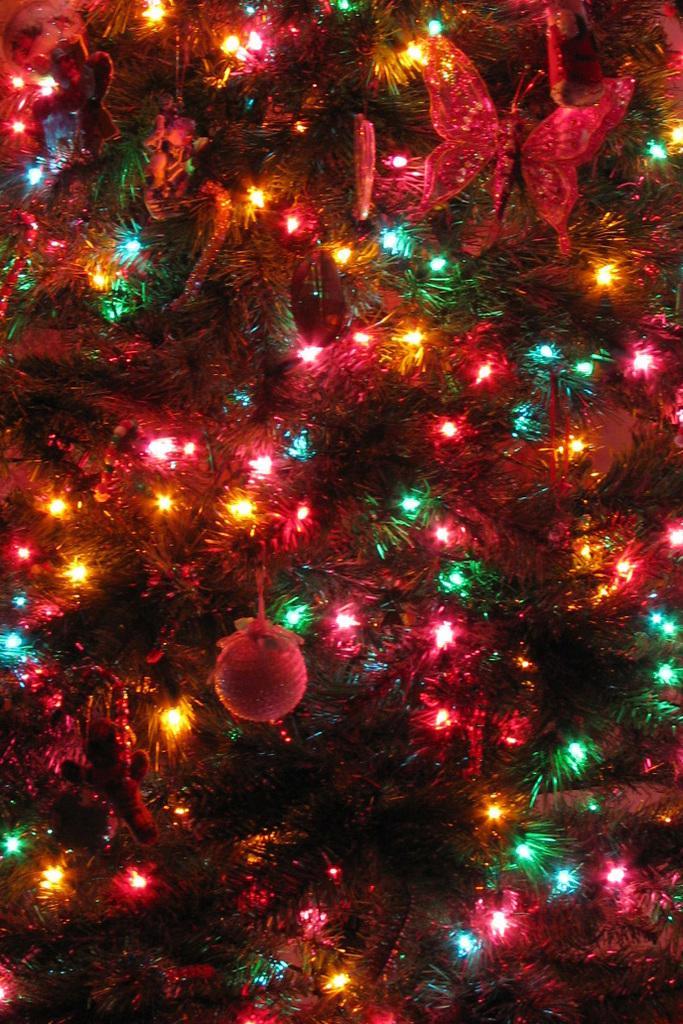Can you describe this image briefly? In the picture I can see the Christmas tree. I can see decorative lights. I can see decorative objects. 